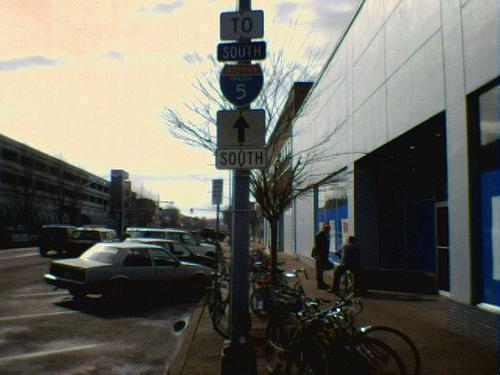Why are the bikes on the poles?
Answer the question by selecting the correct answer among the 4 following choices and explain your choice with a short sentence. The answer should be formatted with the following format: `Answer: choice
Rationale: rationale.`
Options: Lost, for sale, keep safe, stolen. Answer: keep safe.
Rationale: The bikes are temporarily attached to racks next to the poles, or to the poles themselves.  each bike is attached independently of the others with a chain and lock, and a lock reduces risk of theft of the item that is locked up. 